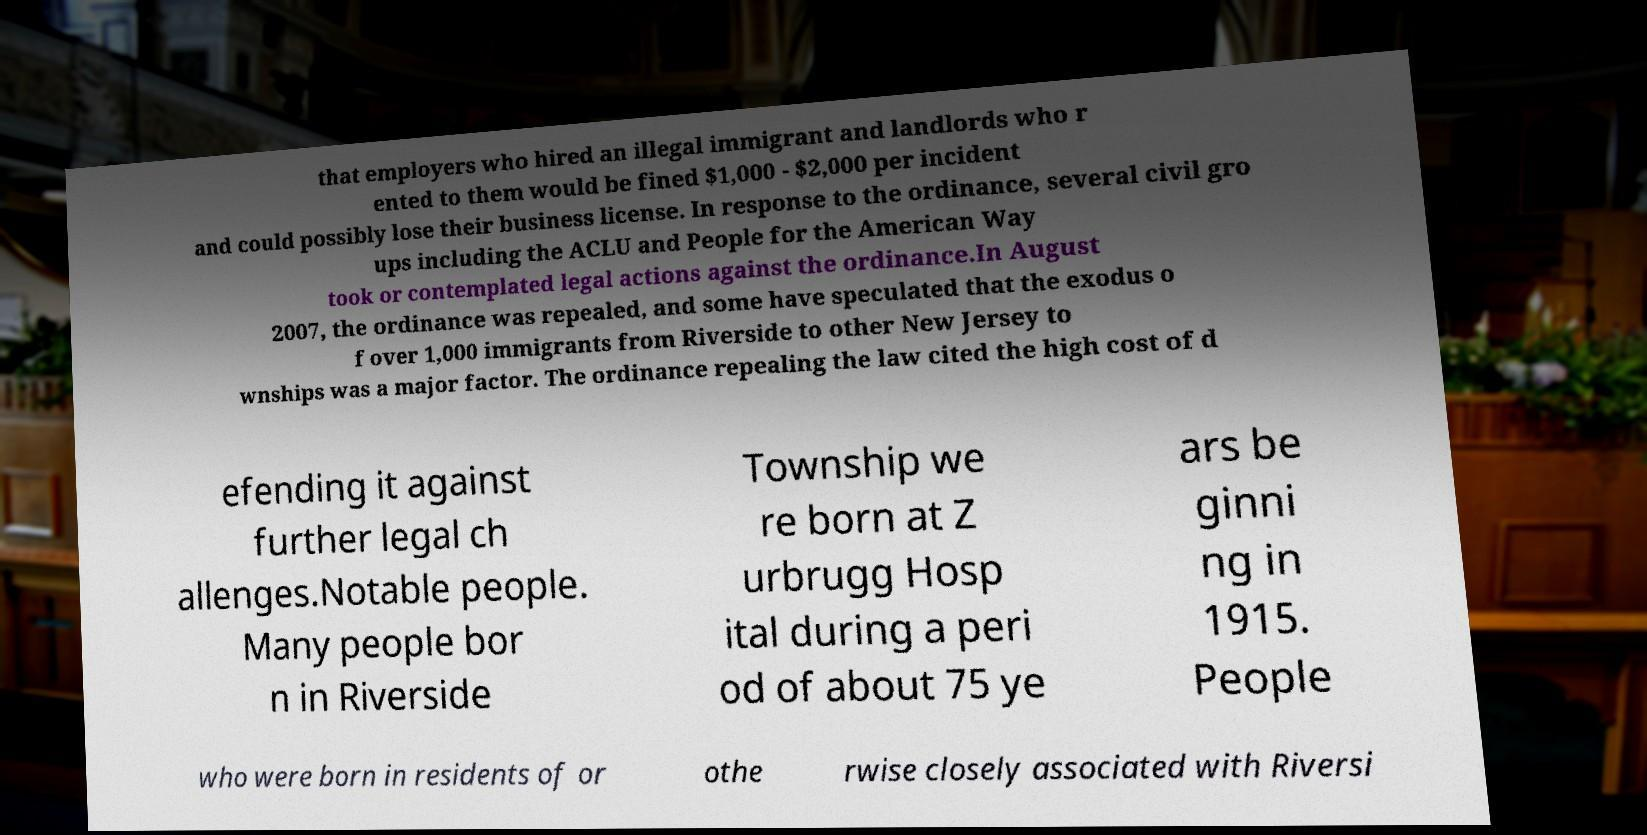I need the written content from this picture converted into text. Can you do that? that employers who hired an illegal immigrant and landlords who r ented to them would be fined $1,000 - $2,000 per incident and could possibly lose their business license. In response to the ordinance, several civil gro ups including the ACLU and People for the American Way took or contemplated legal actions against the ordinance.In August 2007, the ordinance was repealed, and some have speculated that the exodus o f over 1,000 immigrants from Riverside to other New Jersey to wnships was a major factor. The ordinance repealing the law cited the high cost of d efending it against further legal ch allenges.Notable people. Many people bor n in Riverside Township we re born at Z urbrugg Hosp ital during a peri od of about 75 ye ars be ginni ng in 1915. People who were born in residents of or othe rwise closely associated with Riversi 